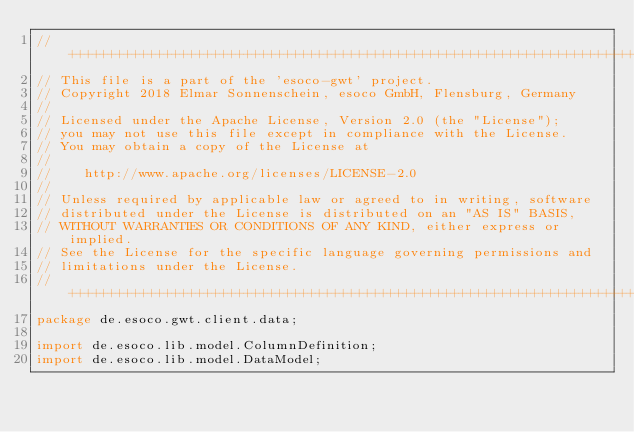Convert code to text. <code><loc_0><loc_0><loc_500><loc_500><_Java_>//++++++++++++++++++++++++++++++++++++++++++++++++++++++++++++++++++++++++++++
// This file is a part of the 'esoco-gwt' project.
// Copyright 2018 Elmar Sonnenschein, esoco GmbH, Flensburg, Germany
//
// Licensed under the Apache License, Version 2.0 (the "License");
// you may not use this file except in compliance with the License.
// You may obtain a copy of the License at
//
//	  http://www.apache.org/licenses/LICENSE-2.0
//
// Unless required by applicable law or agreed to in writing, software
// distributed under the License is distributed on an "AS IS" BASIS,
// WITHOUT WARRANTIES OR CONDITIONS OF ANY KIND, either express or implied.
// See the License for the specific language governing permissions and
// limitations under the License.
//++++++++++++++++++++++++++++++++++++++++++++++++++++++++++++++++++++++++++++
package de.esoco.gwt.client.data;

import de.esoco.lib.model.ColumnDefinition;
import de.esoco.lib.model.DataModel;</code> 